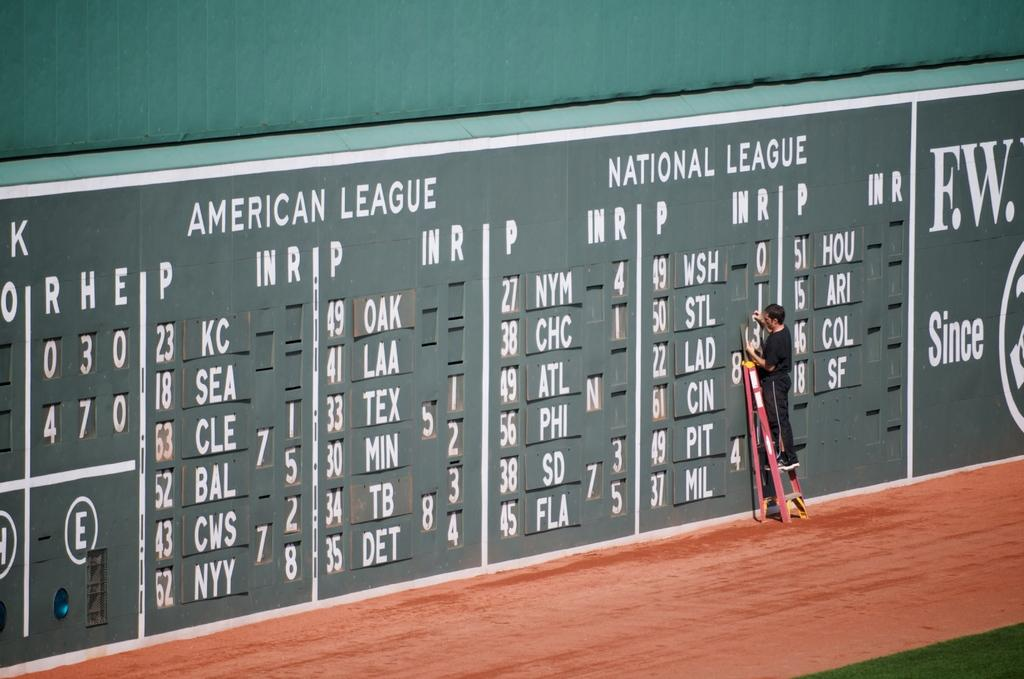Provide a one-sentence caption for the provided image. Person updating the scoreboard for the American League and National League. 